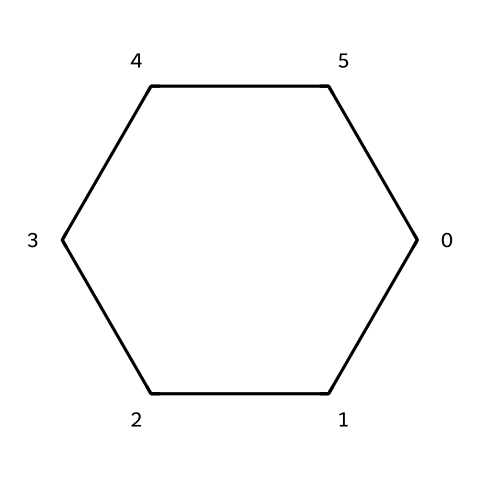What is the name of this chemical? The SMILES representation indicates the structure of a six-membered carbon ring with no double bonds, characteristic of cycloalkanes. Therefore, the name of this chemical is derived from its structure, specifically a six-carbon aliphatic compound.
Answer: cyclohexane How many carbon atoms are in this chemical structure? The SMILES notation 'C1CCCCC1' represents a cyclohexane structure, which indicates that there are six carbon atoms forming a closed ring.
Answer: six How many hydrogen atoms are connected to each carbon in this structure? In cyclohexane, each carbon atom forms two bonds with adjacent carbons and two bonds with hydrogen atoms, resulting in a total of twelve hydrogen atoms for the six carbon atoms in this structure.
Answer: twelve Is this chemical saturated or unsaturated? Cyclohexane, represented by the given SMILES, contains only single C-C bonds and is therefore saturated, meaning it has the maximum number of hydrogen atoms per carbon atom.
Answer: saturated What type of chemical bonding is present in this structure? The SMILES representation shows only single bonds between the carbon atoms (C-C), indicating that the bonding in cyclohexane is covalent and specifically sigma bonding.
Answer: covalent 